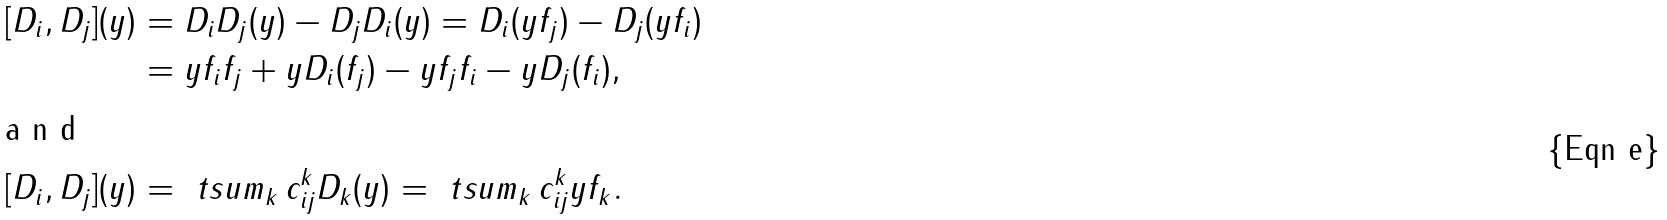<formula> <loc_0><loc_0><loc_500><loc_500>[ D _ { i } , D _ { j } ] ( y ) & = D _ { i } D _ { j } ( y ) - D _ { j } D _ { i } ( y ) = D _ { i } ( y f _ { j } ) - D _ { j } ( y f _ { i } ) \\ & = y f _ { i } f _ { j } + y D _ { i } ( f _ { j } ) - y f _ { j } f _ { i } - y D _ { j } ( f _ { i } ) , \intertext { a n d } [ D _ { i } , D _ { j } ] ( y ) & = \ t s u m _ { k } \, c _ { i j } ^ { k } D _ { k } ( y ) = \ t s u m _ { k } \, c _ { i j } ^ { k } y f _ { k } .</formula> 